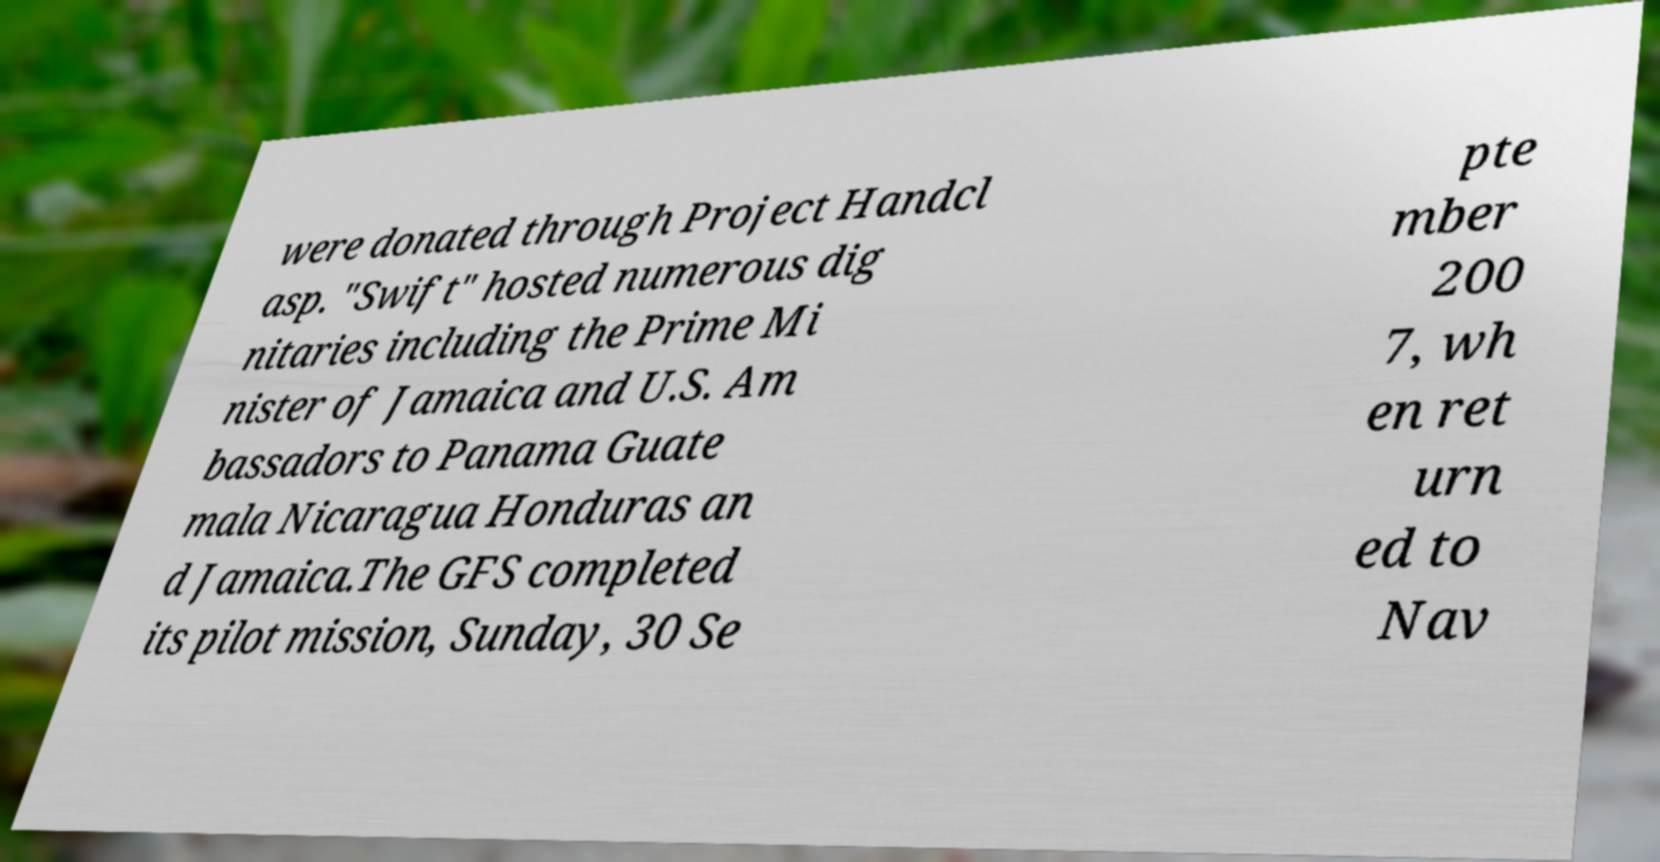For documentation purposes, I need the text within this image transcribed. Could you provide that? were donated through Project Handcl asp. "Swift" hosted numerous dig nitaries including the Prime Mi nister of Jamaica and U.S. Am bassadors to Panama Guate mala Nicaragua Honduras an d Jamaica.The GFS completed its pilot mission, Sunday, 30 Se pte mber 200 7, wh en ret urn ed to Nav 